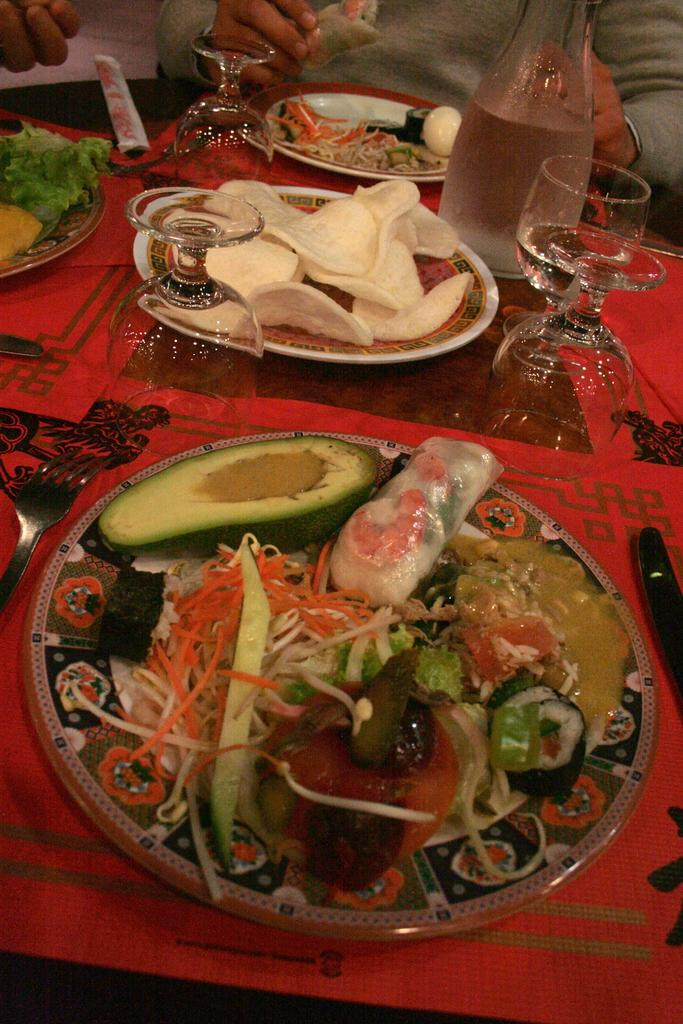What is located at the bottom of the image? There is a table at the bottom of the image. What items can be seen on the table? There are plates, glasses, bowls, food, spoons, forks, and knives on the table. What is the person in the image doing? The person is sitting behind the table. Can you see any ducks playing on the playground in the image? There are no ducks or playground present in the image. What nerve is being stimulated by the person sitting behind the table in the image? The image does not provide information about any nerves being stimulated by the person sitting behind the table. 